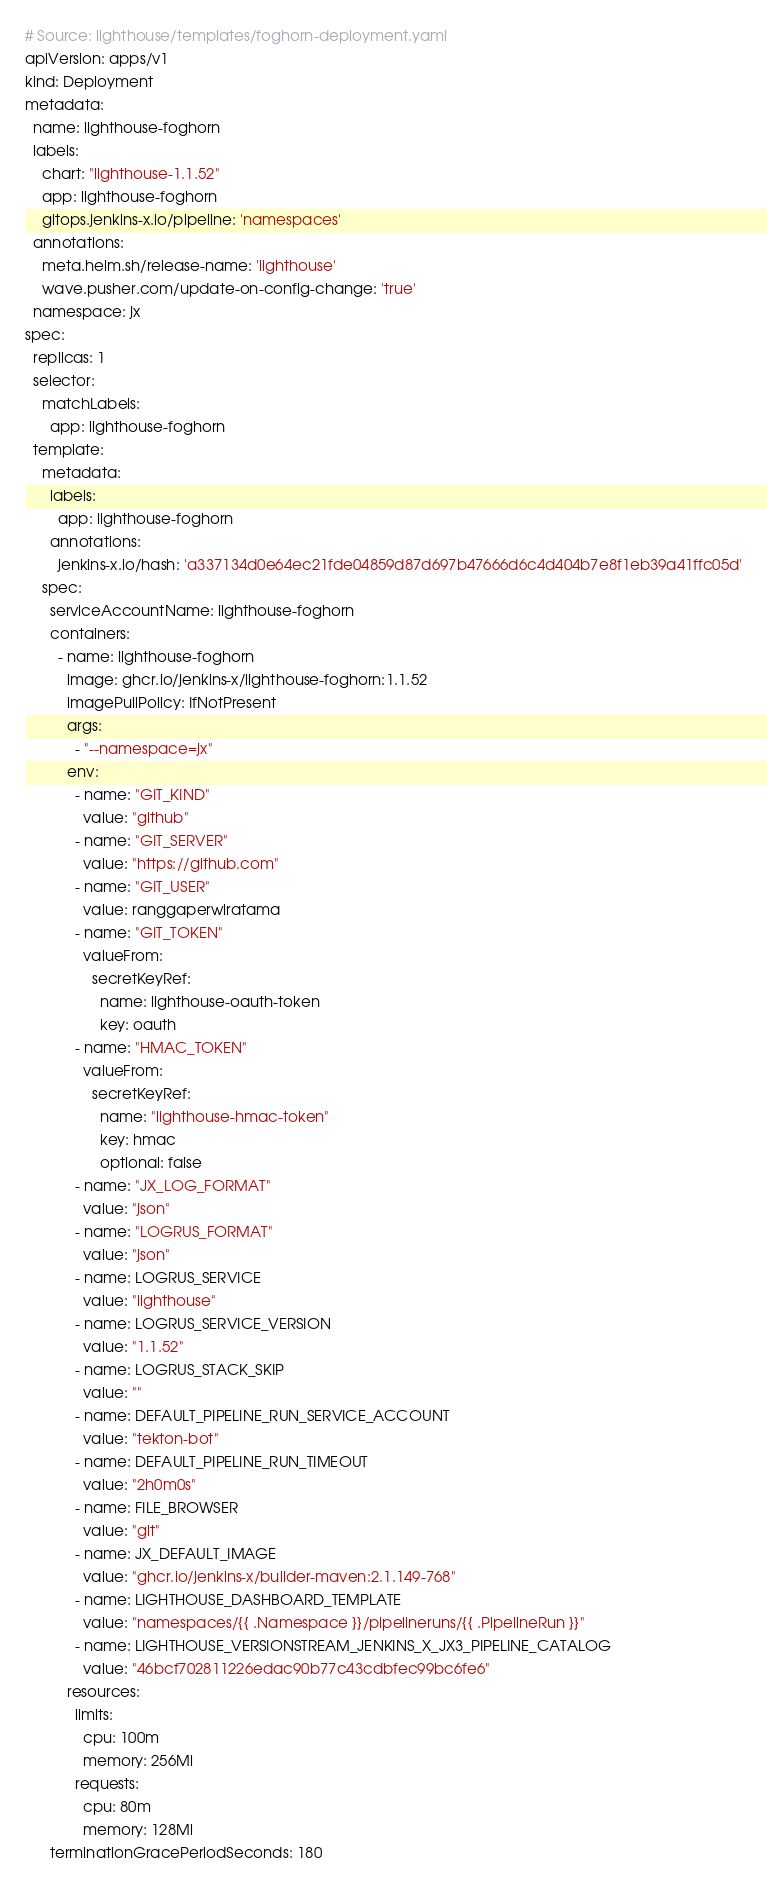Convert code to text. <code><loc_0><loc_0><loc_500><loc_500><_YAML_># Source: lighthouse/templates/foghorn-deployment.yaml
apiVersion: apps/v1
kind: Deployment
metadata:
  name: lighthouse-foghorn
  labels:
    chart: "lighthouse-1.1.52"
    app: lighthouse-foghorn
    gitops.jenkins-x.io/pipeline: 'namespaces'
  annotations:
    meta.helm.sh/release-name: 'lighthouse'
    wave.pusher.com/update-on-config-change: 'true'
  namespace: jx
spec:
  replicas: 1
  selector:
    matchLabels:
      app: lighthouse-foghorn
  template:
    metadata:
      labels:
        app: lighthouse-foghorn
      annotations:
        jenkins-x.io/hash: 'a337134d0e64ec21fde04859d87d697b47666d6c4d404b7e8f1eb39a41ffc05d'
    spec:
      serviceAccountName: lighthouse-foghorn
      containers:
        - name: lighthouse-foghorn
          image: ghcr.io/jenkins-x/lighthouse-foghorn:1.1.52
          imagePullPolicy: IfNotPresent
          args:
            - "--namespace=jx"
          env:
            - name: "GIT_KIND"
              value: "github"
            - name: "GIT_SERVER"
              value: "https://github.com"
            - name: "GIT_USER"
              value: ranggaperwiratama
            - name: "GIT_TOKEN"
              valueFrom:
                secretKeyRef:
                  name: lighthouse-oauth-token
                  key: oauth
            - name: "HMAC_TOKEN"
              valueFrom:
                secretKeyRef:
                  name: "lighthouse-hmac-token"
                  key: hmac
                  optional: false
            - name: "JX_LOG_FORMAT"
              value: "json"
            - name: "LOGRUS_FORMAT"
              value: "json"
            - name: LOGRUS_SERVICE
              value: "lighthouse"
            - name: LOGRUS_SERVICE_VERSION
              value: "1.1.52"
            - name: LOGRUS_STACK_SKIP
              value: ""
            - name: DEFAULT_PIPELINE_RUN_SERVICE_ACCOUNT
              value: "tekton-bot"
            - name: DEFAULT_PIPELINE_RUN_TIMEOUT
              value: "2h0m0s"
            - name: FILE_BROWSER
              value: "git"
            - name: JX_DEFAULT_IMAGE
              value: "ghcr.io/jenkins-x/builder-maven:2.1.149-768"
            - name: LIGHTHOUSE_DASHBOARD_TEMPLATE
              value: "namespaces/{{ .Namespace }}/pipelineruns/{{ .PipelineRun }}"
            - name: LIGHTHOUSE_VERSIONSTREAM_JENKINS_X_JX3_PIPELINE_CATALOG
              value: "46bcf702811226edac90b77c43cdbfec99bc6fe6"
          resources:
            limits:
              cpu: 100m
              memory: 256Mi
            requests:
              cpu: 80m
              memory: 128Mi
      terminationGracePeriodSeconds: 180
</code> 